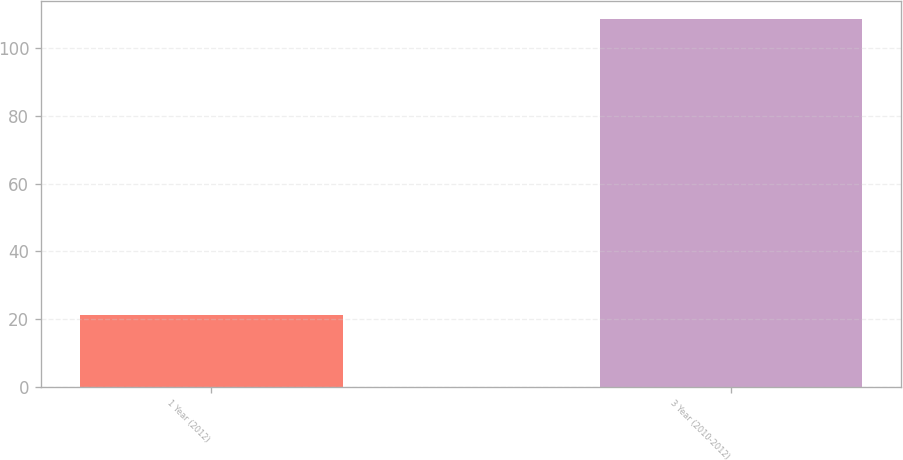Convert chart. <chart><loc_0><loc_0><loc_500><loc_500><bar_chart><fcel>1 Year (2012)<fcel>3 Year (2010-2012)<nl><fcel>21.2<fcel>108.6<nl></chart> 